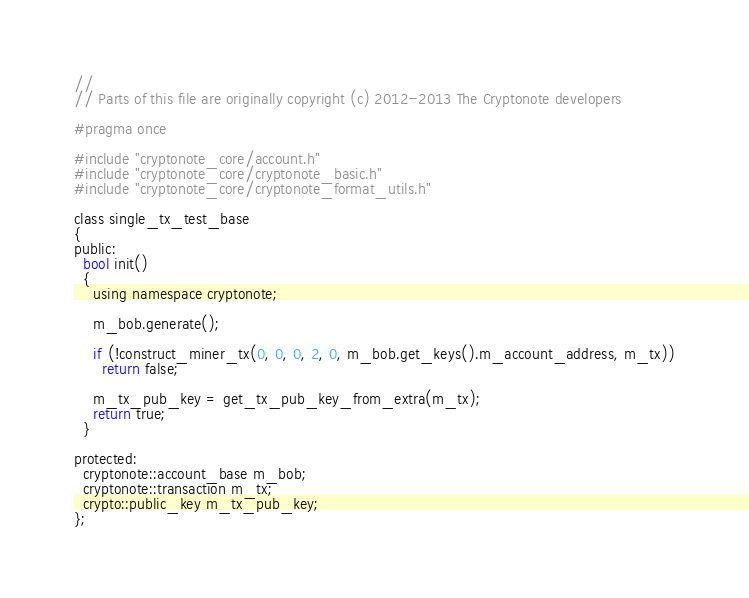<code> <loc_0><loc_0><loc_500><loc_500><_C_>// 
// Parts of this file are originally copyright (c) 2012-2013 The Cryptonote developers

#pragma once

#include "cryptonote_core/account.h"
#include "cryptonote_core/cryptonote_basic.h"
#include "cryptonote_core/cryptonote_format_utils.h"

class single_tx_test_base
{
public:
  bool init()
  {
    using namespace cryptonote;

    m_bob.generate();

    if (!construct_miner_tx(0, 0, 0, 2, 0, m_bob.get_keys().m_account_address, m_tx))
      return false;

    m_tx_pub_key = get_tx_pub_key_from_extra(m_tx);
    return true;
  }

protected:
  cryptonote::account_base m_bob;
  cryptonote::transaction m_tx;
  crypto::public_key m_tx_pub_key;
};
</code> 